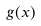<formula> <loc_0><loc_0><loc_500><loc_500>g ( x )</formula> 